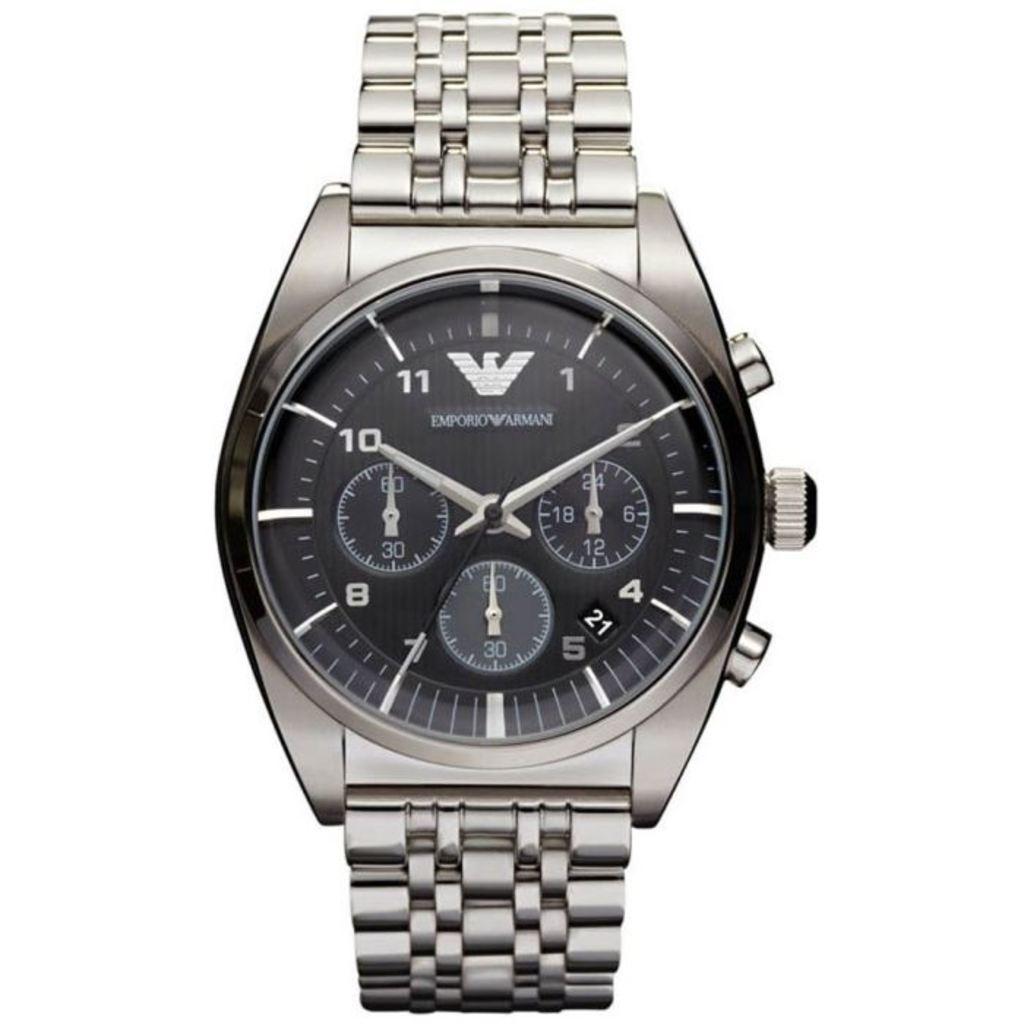What number is the long hand pointing to?
Keep it short and to the point. 2. What is the time shown?
Provide a succinct answer. 10:10. 